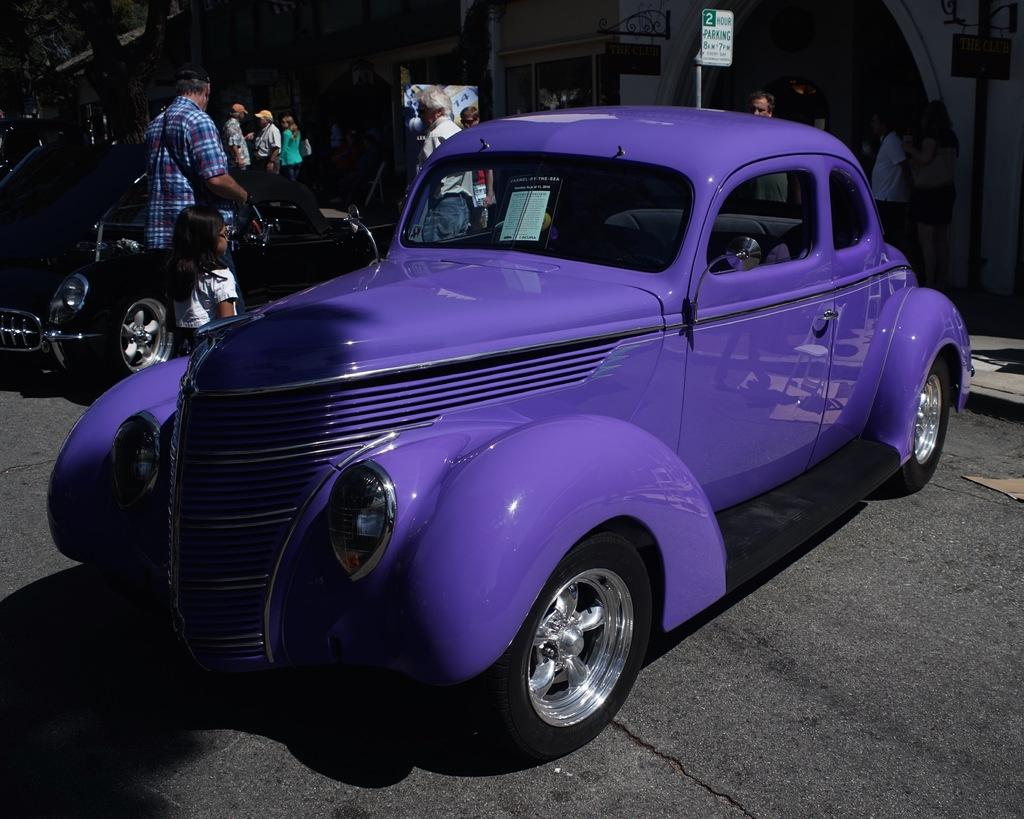What type of vehicles can be seen on the road in the image? There are cars on the road in the image. What else can be seen in the background of the image? There are people standing in the background of the image, as well as a sign board and a building. What type of vest is being worn by the plate in the image? There is no vest or plate present in the image. 